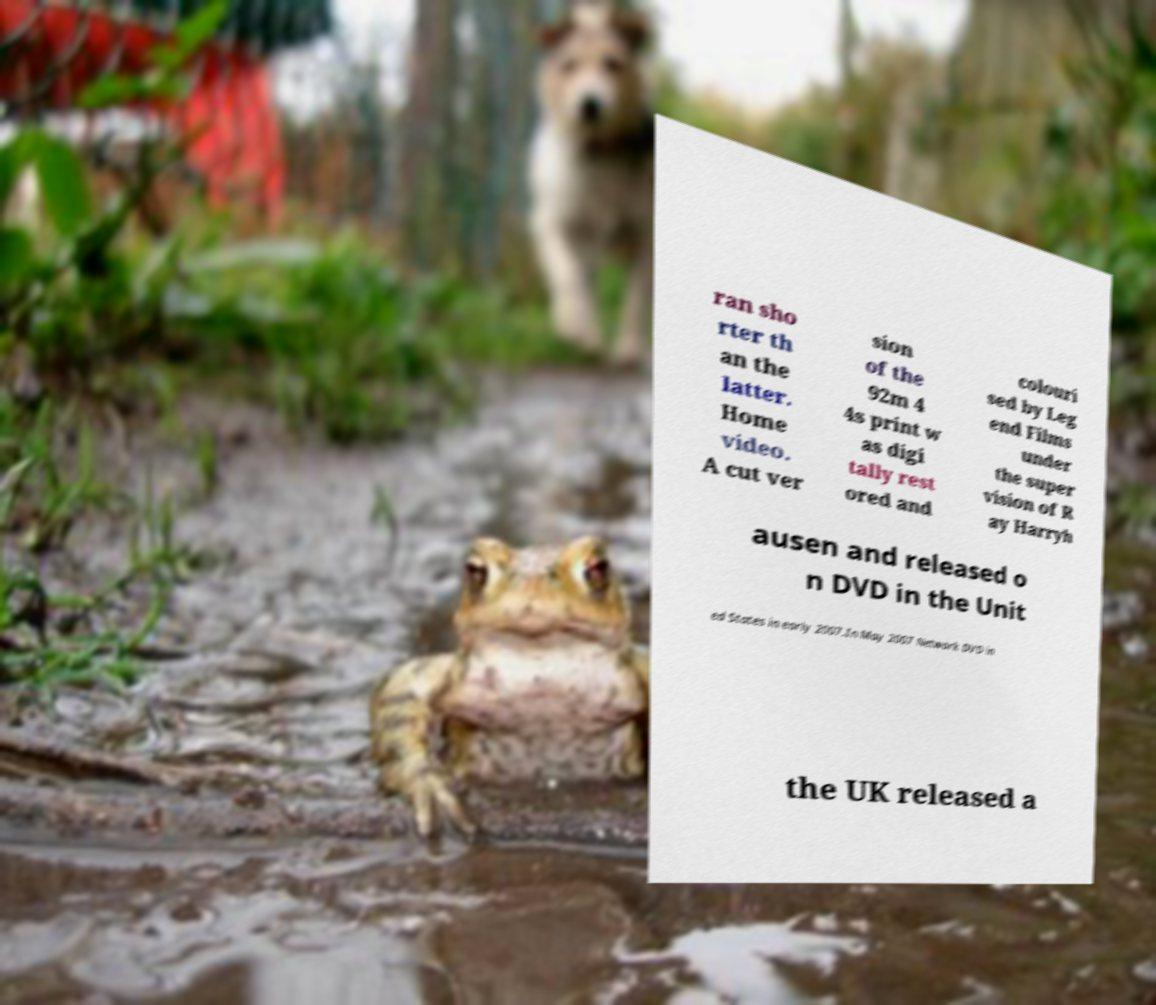There's text embedded in this image that I need extracted. Can you transcribe it verbatim? ran sho rter th an the latter. Home video. A cut ver sion of the 92m 4 4s print w as digi tally rest ored and colouri sed by Leg end Films under the super vision of R ay Harryh ausen and released o n DVD in the Unit ed States in early 2007.In May 2007 Network DVD in the UK released a 